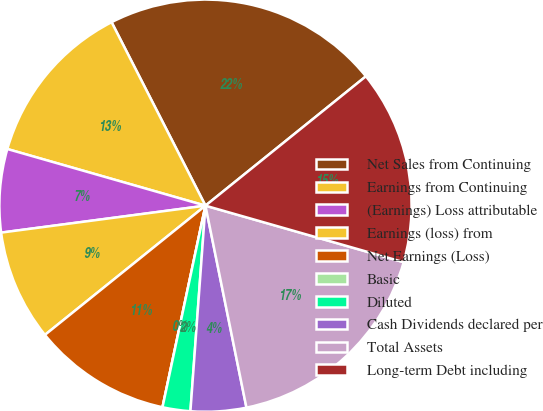<chart> <loc_0><loc_0><loc_500><loc_500><pie_chart><fcel>Net Sales from Continuing<fcel>Earnings from Continuing<fcel>(Earnings) Loss attributable<fcel>Earnings (loss) from<fcel>Net Earnings (Loss)<fcel>Basic<fcel>Diluted<fcel>Cash Dividends declared per<fcel>Total Assets<fcel>Long-term Debt including<nl><fcel>21.73%<fcel>13.04%<fcel>6.52%<fcel>8.7%<fcel>10.87%<fcel>0.0%<fcel>2.18%<fcel>4.35%<fcel>17.39%<fcel>15.22%<nl></chart> 